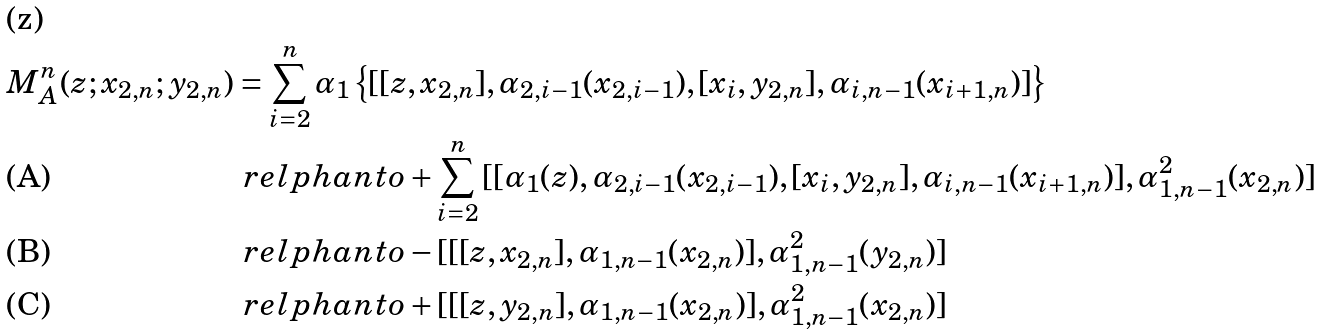Convert formula to latex. <formula><loc_0><loc_0><loc_500><loc_500>M ^ { n } _ { A } ( z ; x _ { 2 , n } ; y _ { 2 , n } ) & = \sum _ { i = 2 } ^ { n } \alpha _ { 1 } \left \{ [ [ z , x _ { 2 , n } ] , \alpha _ { 2 , i - 1 } ( x _ { 2 , i - 1 } ) , [ x _ { i } , y _ { 2 , n } ] , \alpha _ { i , n - 1 } ( x _ { i + 1 , n } ) ] \right \} \\ & \ r e l p h a n t o + \sum _ { i = 2 } ^ { n } \, [ [ \alpha _ { 1 } ( z ) , \alpha _ { 2 , i - 1 } ( x _ { 2 , i - 1 } ) , [ x _ { i } , y _ { 2 , n } ] , \alpha _ { i , n - 1 } ( x _ { i + 1 , n } ) ] , \alpha ^ { 2 } _ { 1 , n - 1 } ( x _ { 2 , n } ) ] \\ & \ r e l p h a n t o - [ [ [ z , x _ { 2 , n } ] , \alpha _ { 1 , n - 1 } ( x _ { 2 , n } ) ] , \alpha ^ { 2 } _ { 1 , n - 1 } ( y _ { 2 , n } ) ] \\ & \ r e l p h a n t o + [ [ [ z , y _ { 2 , n } ] , \alpha _ { 1 , n - 1 } ( x _ { 2 , n } ) ] , \alpha ^ { 2 } _ { 1 , n - 1 } ( x _ { 2 , n } ) ]</formula> 